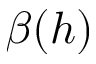<formula> <loc_0><loc_0><loc_500><loc_500>\beta ( h )</formula> 